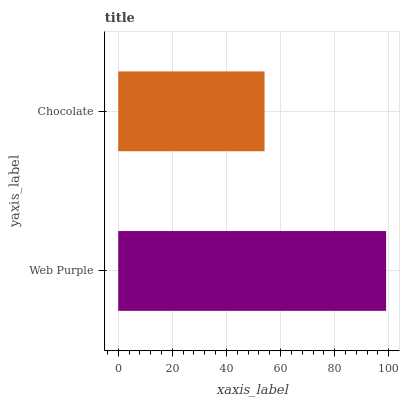Is Chocolate the minimum?
Answer yes or no. Yes. Is Web Purple the maximum?
Answer yes or no. Yes. Is Chocolate the maximum?
Answer yes or no. No. Is Web Purple greater than Chocolate?
Answer yes or no. Yes. Is Chocolate less than Web Purple?
Answer yes or no. Yes. Is Chocolate greater than Web Purple?
Answer yes or no. No. Is Web Purple less than Chocolate?
Answer yes or no. No. Is Web Purple the high median?
Answer yes or no. Yes. Is Chocolate the low median?
Answer yes or no. Yes. Is Chocolate the high median?
Answer yes or no. No. Is Web Purple the low median?
Answer yes or no. No. 